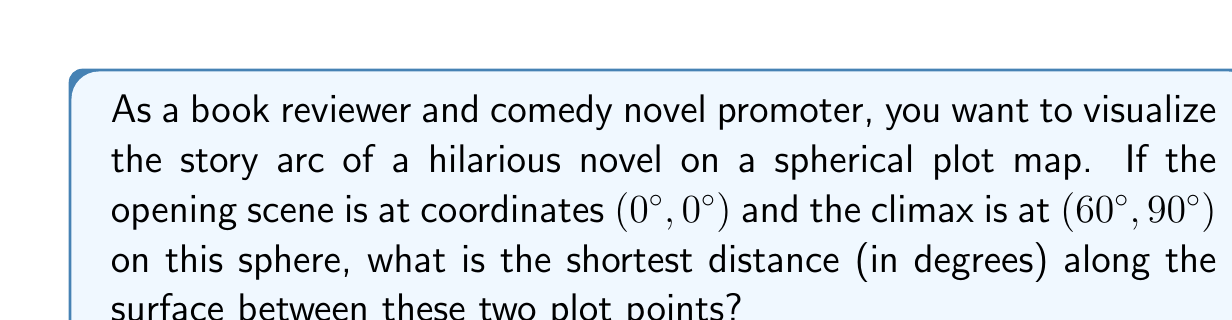Teach me how to tackle this problem. Let's approach this step-by-step:

1) The geodesic path between two points on a sphere is the great circle arc connecting them. The length of this arc is proportional to the central angle between the two points.

2) To find the central angle, we can use the spherical law of cosines:

   $$\cos(c) = \sin(a)\sin(b) + \cos(a)\cos(b)\cos(C)$$

   where $c$ is the central angle we're looking for, $a$ and $b$ are the latitudes of the two points, and $C$ is the difference in longitudes.

3) In our case:
   $a = 0°$ (latitude of the opening scene)
   $b = 60°$ (latitude of the climax)
   $C = 90°$ (difference in longitudes)

4) Plugging these into the formula:

   $$\cos(c) = \sin(0°)\sin(60°) + \cos(0°)\cos(60°)\cos(90°)$$

5) Simplify:
   $$\cos(c) = 0 \cdot \frac{\sqrt{3}}{2} + 1 \cdot \frac{1}{2} \cdot 0 = 0$$

6) Therefore:
   $$c = \arccos(0) = 90°$$

7) The shortest distance along the surface is the same as this central angle when measured in degrees on a unit sphere.

[asy]
import geometry;

size(200);
pen p = rgb(0,0,1);
draw(circle((0,0),1),p);
dot((1,0),p);
dot((0,1),p);
label("Opening (0°,0°)",(1,0),E);
label("Climax (60°,90°)",(0,1),N);
draw((1,0)--(0,1),p);
[/asy]
Answer: 90° 